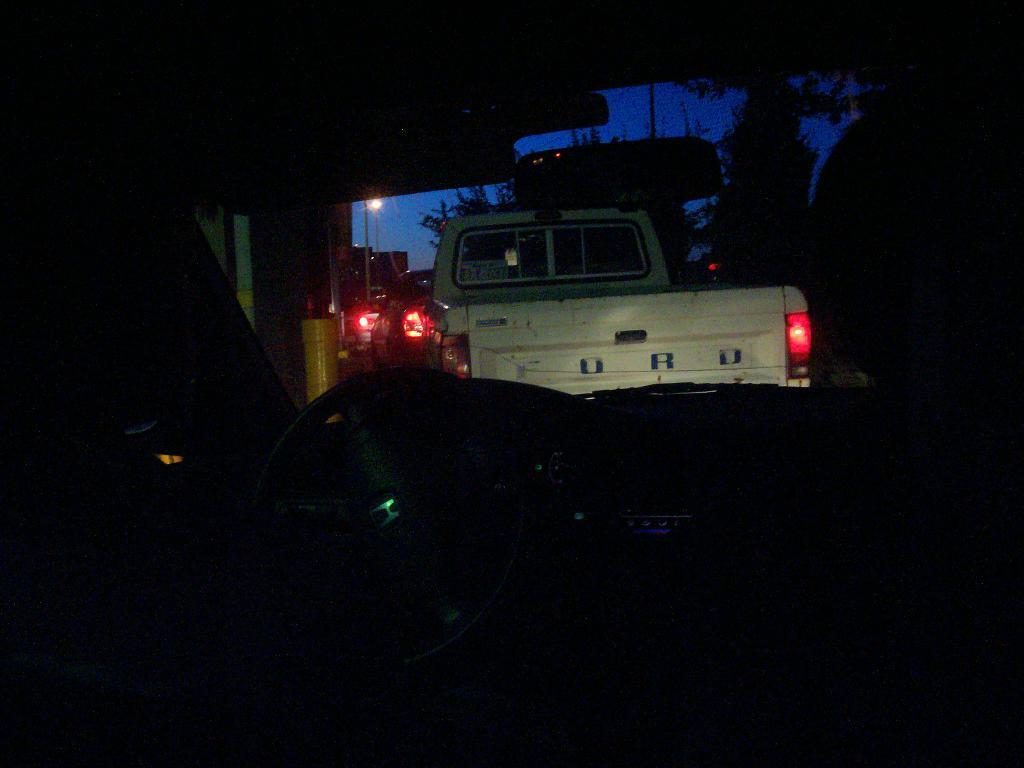What can be seen in the image in terms of vehicles? There are groups of cars in the image. What color lights are visible in the image? There are red lights visible in the image. What part of the natural environment is visible in the image? The sky is visible at the top of the image. Where is the map located in the image? There is no map present in the image. How many boys are visible in the image? There are no boys visible in the image. 